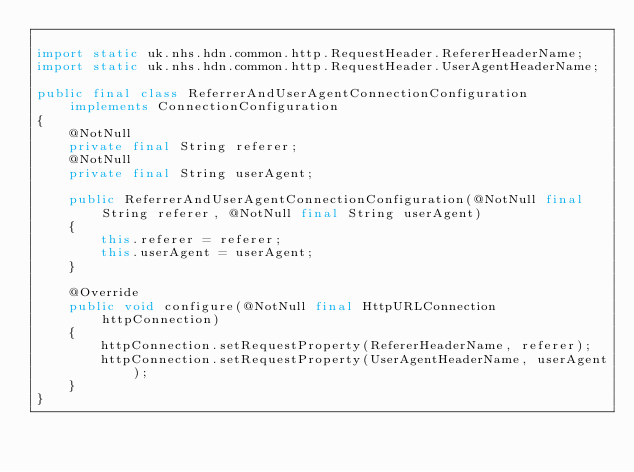Convert code to text. <code><loc_0><loc_0><loc_500><loc_500><_Java_>
import static uk.nhs.hdn.common.http.RequestHeader.RefererHeaderName;
import static uk.nhs.hdn.common.http.RequestHeader.UserAgentHeaderName;

public final class ReferrerAndUserAgentConnectionConfiguration implements ConnectionConfiguration
{
	@NotNull
	private final String referer;
	@NotNull
	private final String userAgent;

	public ReferrerAndUserAgentConnectionConfiguration(@NotNull final String referer, @NotNull final String userAgent)
	{
		this.referer = referer;
		this.userAgent = userAgent;
	}

	@Override
	public void configure(@NotNull final HttpURLConnection httpConnection)
	{
		httpConnection.setRequestProperty(RefererHeaderName, referer);
		httpConnection.setRequestProperty(UserAgentHeaderName, userAgent);
	}
}
</code> 